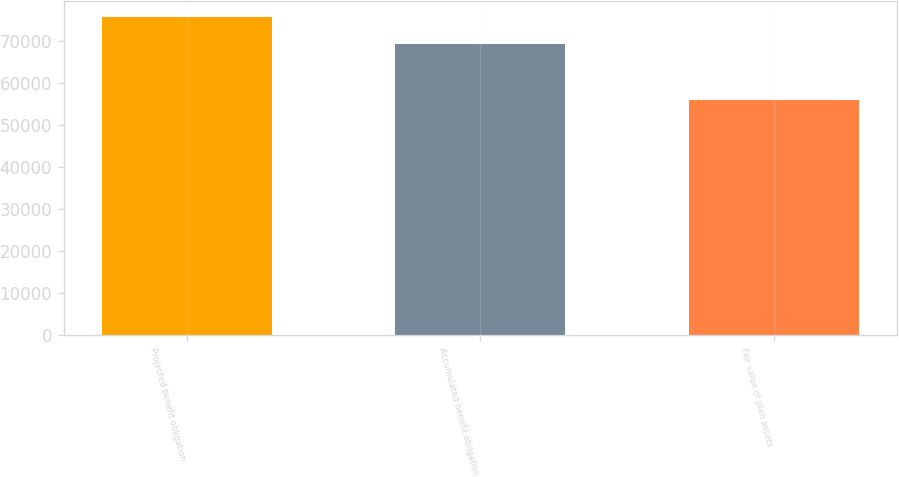Convert chart to OTSL. <chart><loc_0><loc_0><loc_500><loc_500><bar_chart><fcel>Projected benefit obligation<fcel>Accumulated benefit obligation<fcel>Fair value of plan assets<nl><fcel>75851<fcel>69272<fcel>56129<nl></chart> 